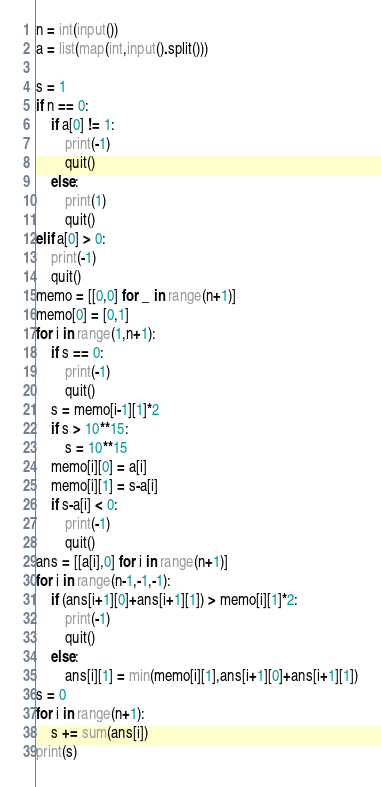<code> <loc_0><loc_0><loc_500><loc_500><_Python_>n = int(input())
a = list(map(int,input().split()))

s = 1
if n == 0:
    if a[0] != 1:
        print(-1)
        quit()
    else:
        print(1)
        quit()
elif a[0] > 0:
    print(-1)
    quit()
memo = [[0,0] for _ in range(n+1)]
memo[0] = [0,1]
for i in range(1,n+1):
    if s == 0:
        print(-1)
        quit()
    s = memo[i-1][1]*2
    if s > 10**15:
        s = 10**15
    memo[i][0] = a[i]
    memo[i][1] = s-a[i]
    if s-a[i] < 0:
        print(-1)
        quit()
ans = [[a[i],0] for i in range(n+1)]
for i in range(n-1,-1,-1):
    if (ans[i+1][0]+ans[i+1][1]) > memo[i][1]*2:
        print(-1)
        quit()
    else:
        ans[i][1] = min(memo[i][1],ans[i+1][0]+ans[i+1][1])
s = 0
for i in range(n+1):
    s += sum(ans[i])
print(s)</code> 